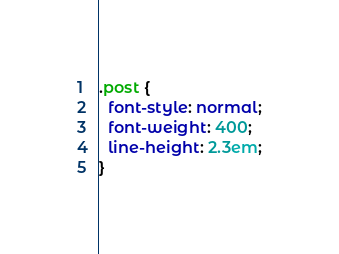<code> <loc_0><loc_0><loc_500><loc_500><_CSS_>.post {
  font-style: normal;
  font-weight: 400;
  line-height: 2.3em;
}
</code> 